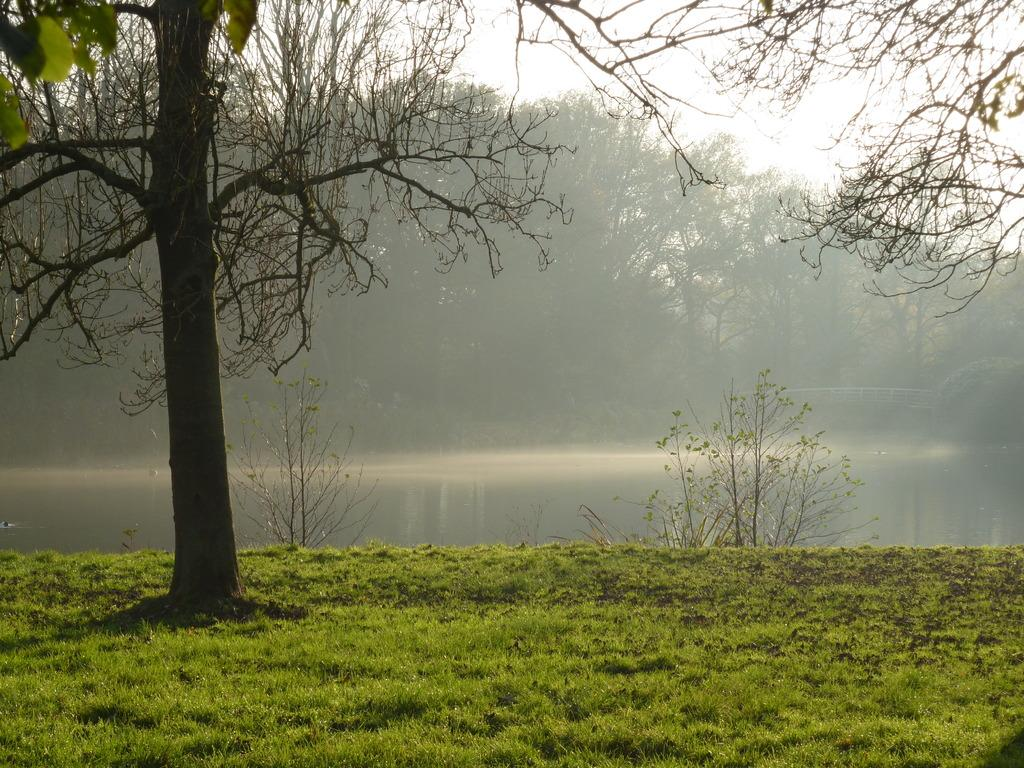What type of vegetation can be seen in the image? There are many trees, plants, and grass in the image. What is located in the center of the image? There is a water flow in the center of the image. What is visible at the top of the image? The sky is visible at the top of the image. How many lumberjacks are working in the image? There are no lumberjacks or any indication of logging activity present in the image. Can you tell me how many horses are grazing in the grass? There are no horses visible in the image; it features trees, plants, grass, and a water flow. 